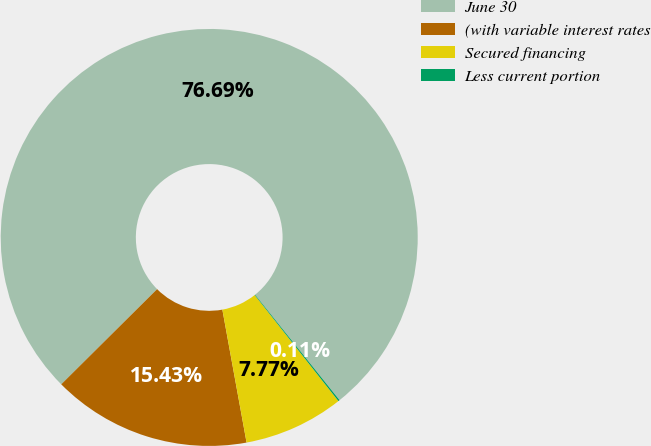Convert chart to OTSL. <chart><loc_0><loc_0><loc_500><loc_500><pie_chart><fcel>June 30<fcel>(with variable interest rates<fcel>Secured financing<fcel>Less current portion<nl><fcel>76.7%<fcel>15.43%<fcel>7.77%<fcel>0.11%<nl></chart> 